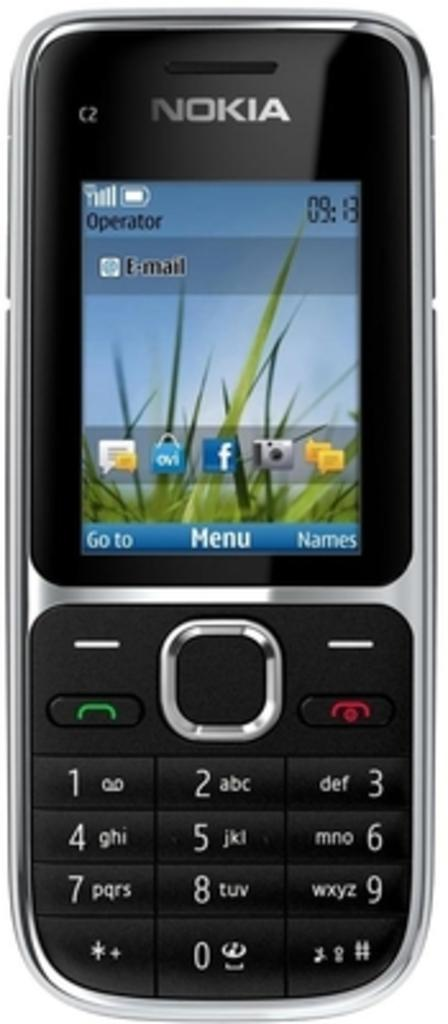<image>
Provide a brief description of the given image. A Nokia phone shows the time is 9:13. 